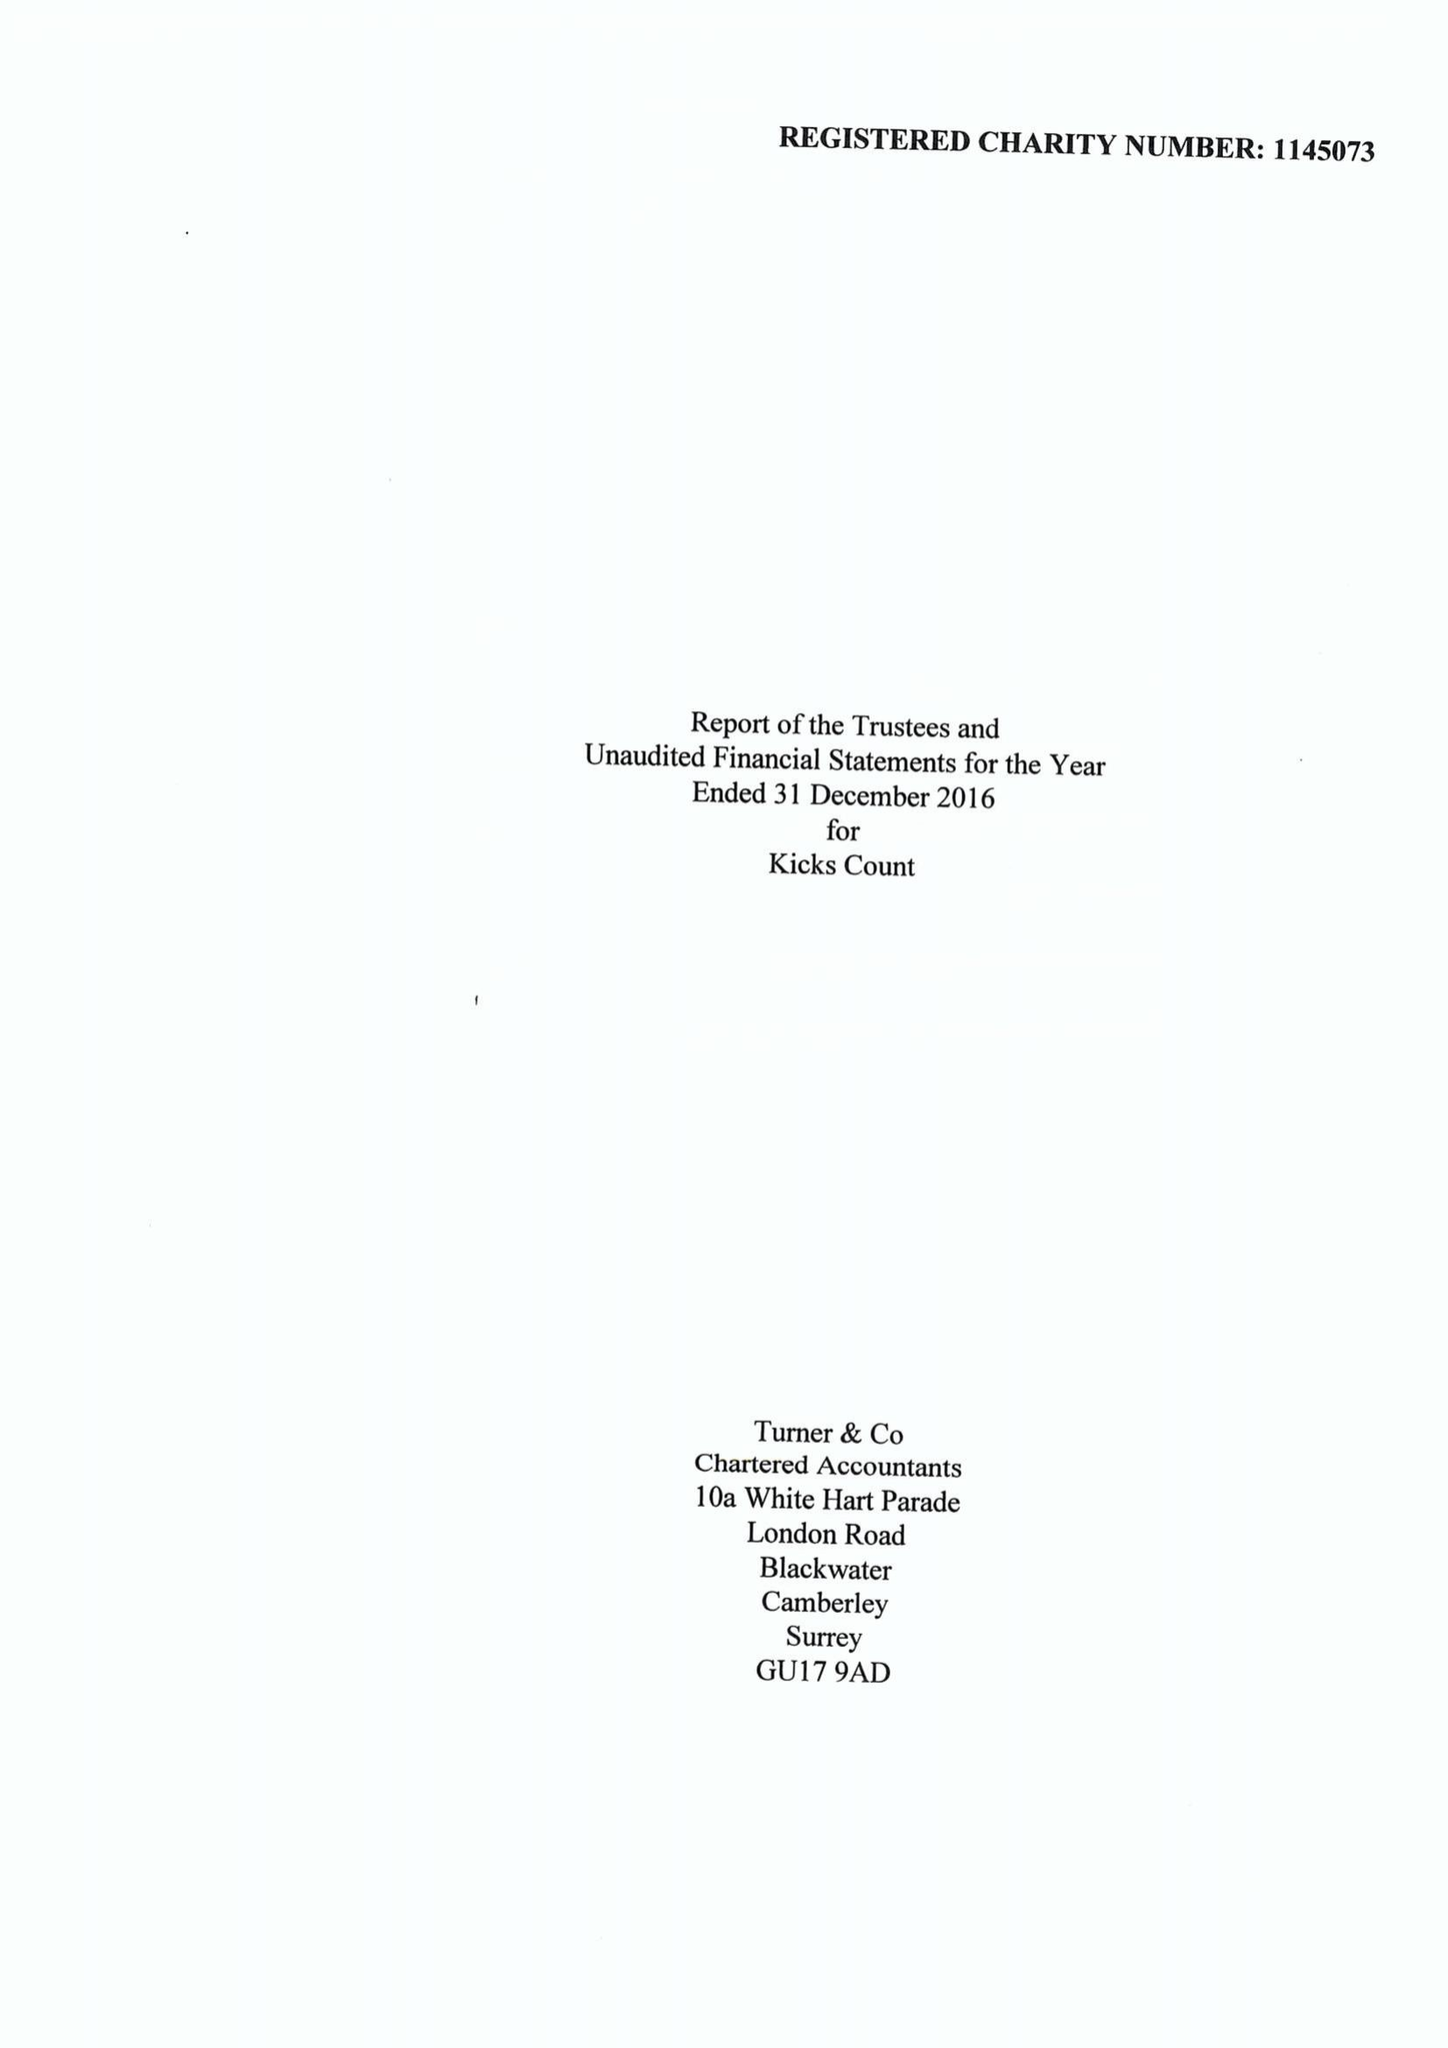What is the value for the charity_name?
Answer the question using a single word or phrase. Kicks Count 